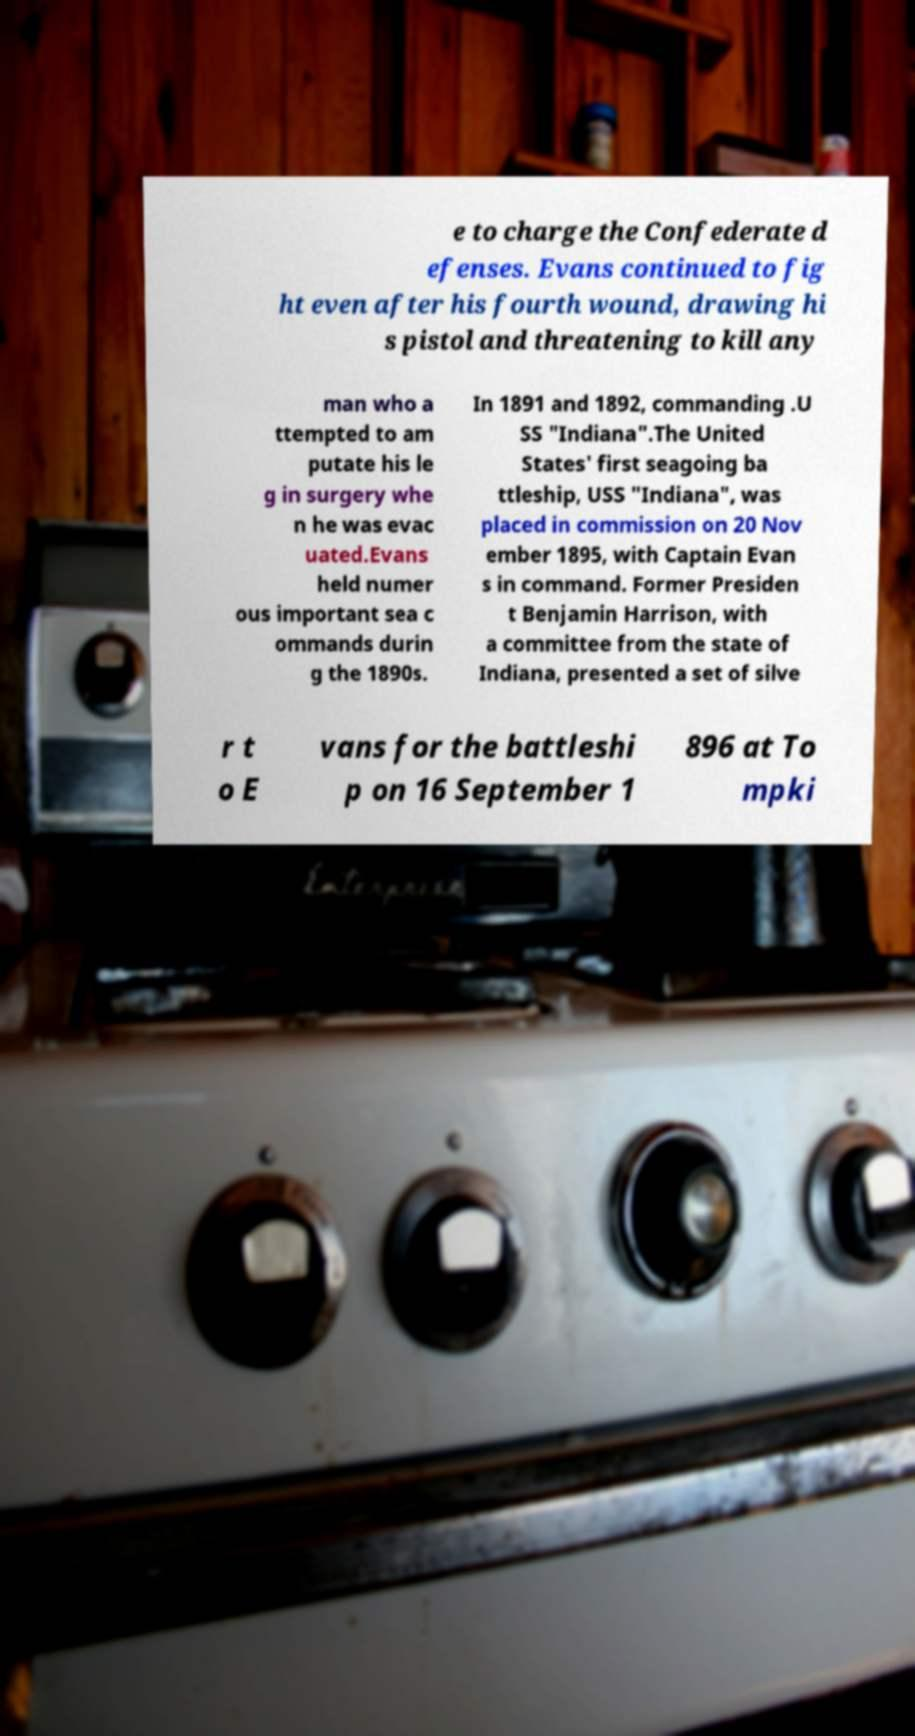Please read and relay the text visible in this image. What does it say? e to charge the Confederate d efenses. Evans continued to fig ht even after his fourth wound, drawing hi s pistol and threatening to kill any man who a ttempted to am putate his le g in surgery whe n he was evac uated.Evans held numer ous important sea c ommands durin g the 1890s. In 1891 and 1892, commanding .U SS "Indiana".The United States' first seagoing ba ttleship, USS "Indiana", was placed in commission on 20 Nov ember 1895, with Captain Evan s in command. Former Presiden t Benjamin Harrison, with a committee from the state of Indiana, presented a set of silve r t o E vans for the battleshi p on 16 September 1 896 at To mpki 